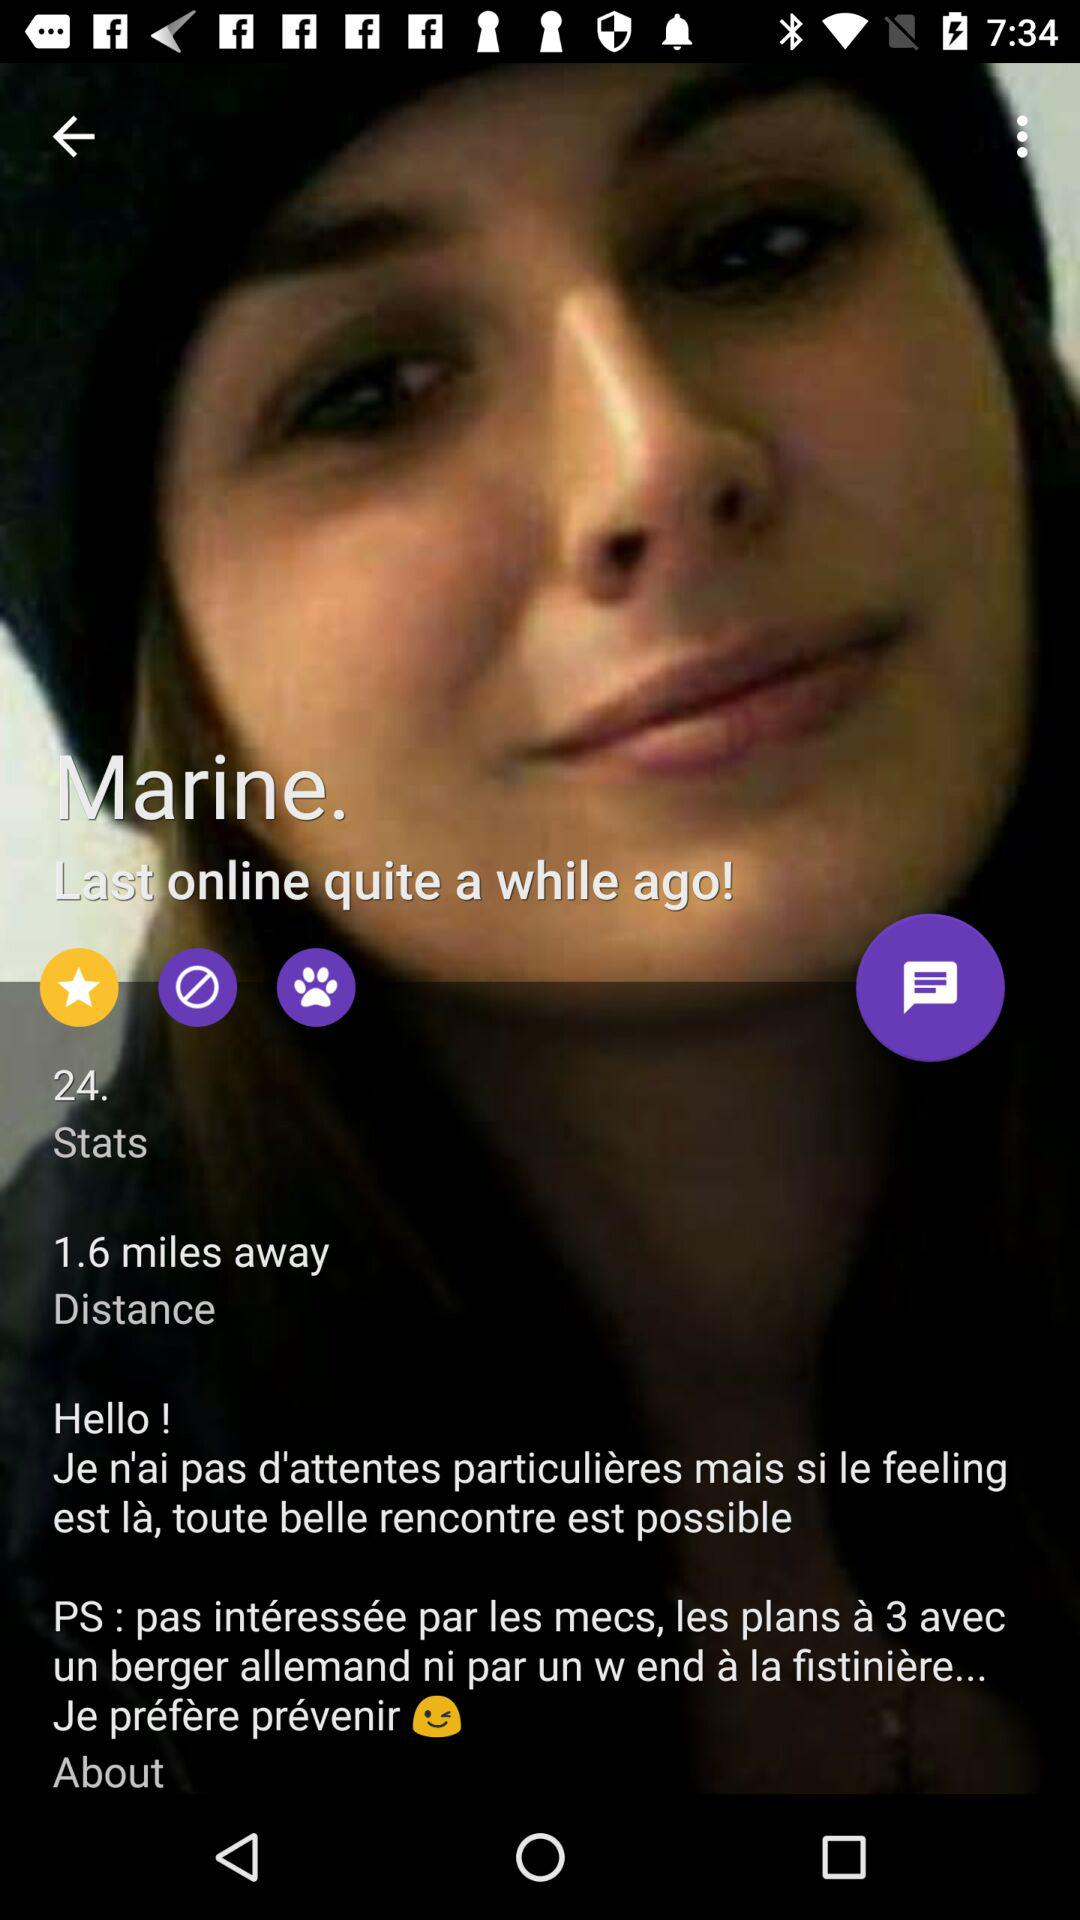When did the marine last go online?
Answer the question using a single word or phrase. The marine was last seen online quite some time ago! 